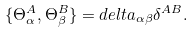Convert formula to latex. <formula><loc_0><loc_0><loc_500><loc_500>\{ \Theta _ { \alpha } ^ { A } , \Theta _ { \beta } ^ { B } \} = d e l t a _ { \alpha \beta } \delta ^ { A B } .</formula> 